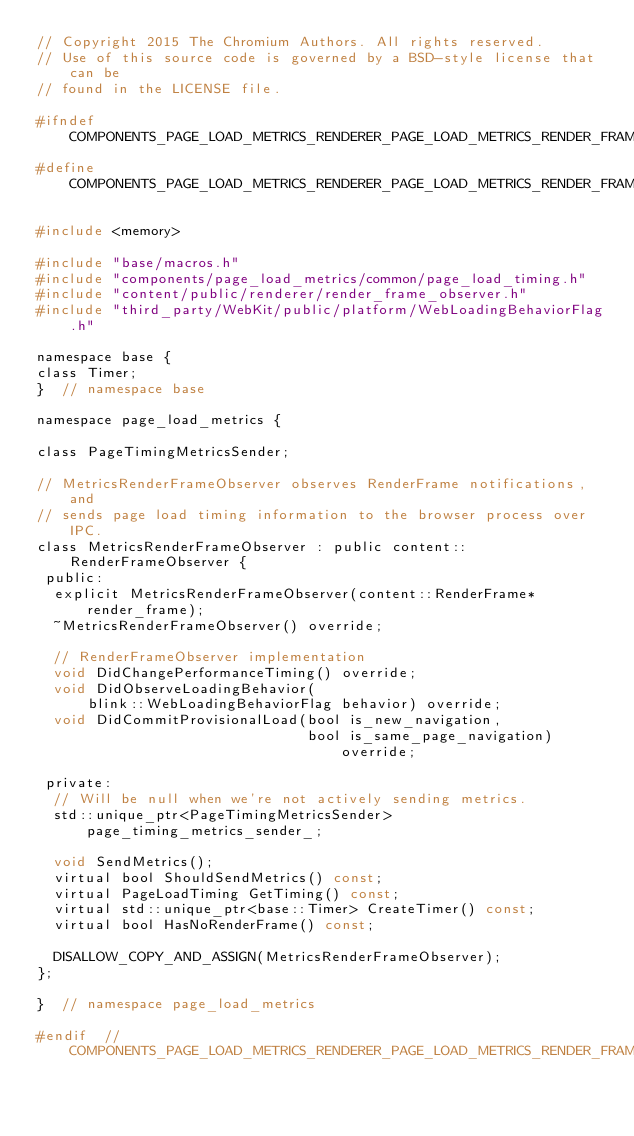<code> <loc_0><loc_0><loc_500><loc_500><_C_>// Copyright 2015 The Chromium Authors. All rights reserved.
// Use of this source code is governed by a BSD-style license that can be
// found in the LICENSE file.

#ifndef COMPONENTS_PAGE_LOAD_METRICS_RENDERER_PAGE_LOAD_METRICS_RENDER_FRAME_OBSERVER_H_
#define COMPONENTS_PAGE_LOAD_METRICS_RENDERER_PAGE_LOAD_METRICS_RENDER_FRAME_OBSERVER_H_

#include <memory>

#include "base/macros.h"
#include "components/page_load_metrics/common/page_load_timing.h"
#include "content/public/renderer/render_frame_observer.h"
#include "third_party/WebKit/public/platform/WebLoadingBehaviorFlag.h"

namespace base {
class Timer;
}  // namespace base

namespace page_load_metrics {

class PageTimingMetricsSender;

// MetricsRenderFrameObserver observes RenderFrame notifications, and
// sends page load timing information to the browser process over IPC.
class MetricsRenderFrameObserver : public content::RenderFrameObserver {
 public:
  explicit MetricsRenderFrameObserver(content::RenderFrame* render_frame);
  ~MetricsRenderFrameObserver() override;

  // RenderFrameObserver implementation
  void DidChangePerformanceTiming() override;
  void DidObserveLoadingBehavior(
      blink::WebLoadingBehaviorFlag behavior) override;
  void DidCommitProvisionalLoad(bool is_new_navigation,
                                bool is_same_page_navigation) override;

 private:
  // Will be null when we're not actively sending metrics.
  std::unique_ptr<PageTimingMetricsSender> page_timing_metrics_sender_;

  void SendMetrics();
  virtual bool ShouldSendMetrics() const;
  virtual PageLoadTiming GetTiming() const;
  virtual std::unique_ptr<base::Timer> CreateTimer() const;
  virtual bool HasNoRenderFrame() const;

  DISALLOW_COPY_AND_ASSIGN(MetricsRenderFrameObserver);
};

}  // namespace page_load_metrics

#endif  // COMPONENTS_PAGE_LOAD_METRICS_RENDERER_PAGE_LOAD_METRICS_RENDER_FRAME_OBSERVER_H_
</code> 